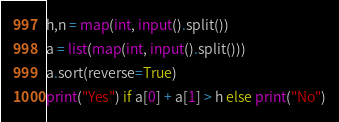Convert code to text. <code><loc_0><loc_0><loc_500><loc_500><_Python_>h,n = map(int, input().split())
a = list(map(int, input().split()))
a.sort(reverse=True)
print("Yes") if a[0] + a[1] > h else print("No")</code> 